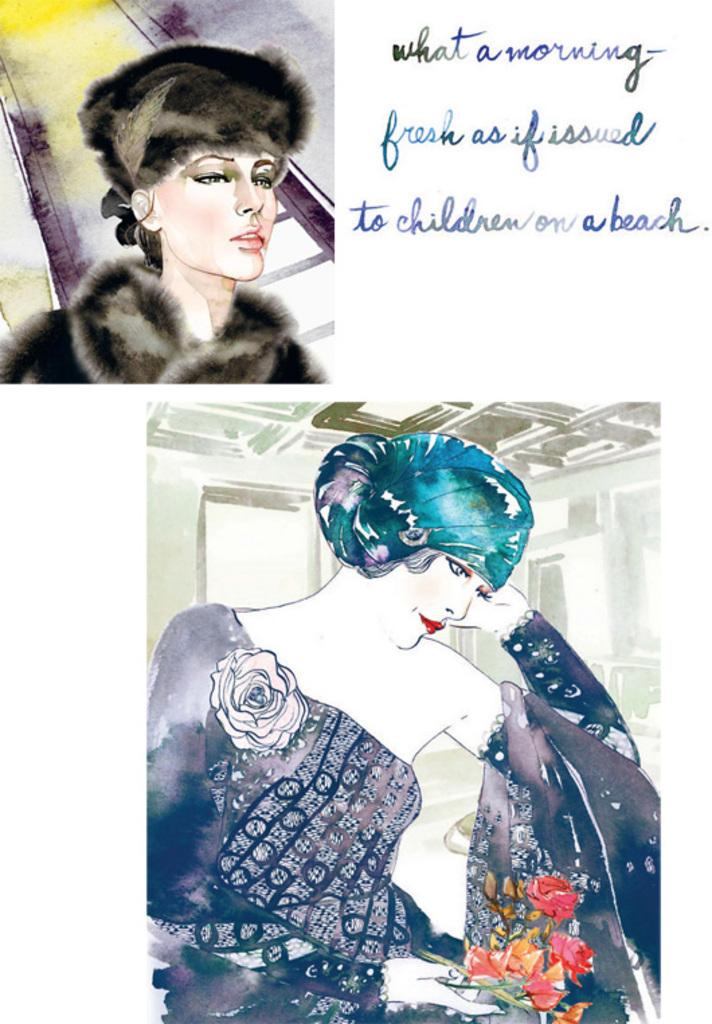What is depicted in the two images in the picture? There are two images of a painting of a woman in the picture. What can be found beside the paintings? There are notes beside the paintings. What type of glass can be seen in the painting of the woman? There is no glass present in the painting of the woman; it is a two-dimensional representation of a woman. 